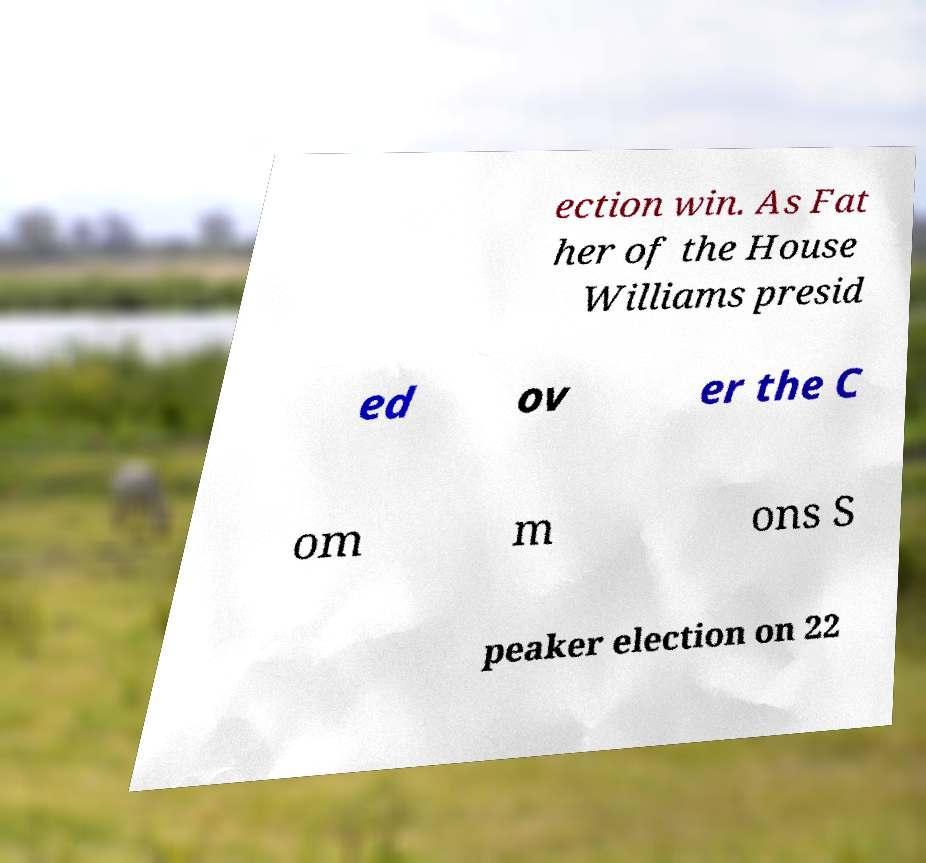I need the written content from this picture converted into text. Can you do that? ection win. As Fat her of the House Williams presid ed ov er the C om m ons S peaker election on 22 